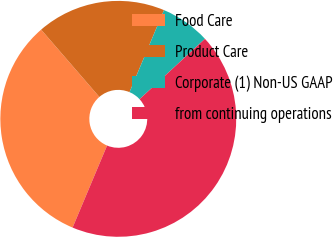Convert chart. <chart><loc_0><loc_0><loc_500><loc_500><pie_chart><fcel>Food Care<fcel>Product Care<fcel>Corporate (1) Non-US GAAP<fcel>from continuing operations<nl><fcel>32.32%<fcel>17.68%<fcel>6.8%<fcel>43.2%<nl></chart> 